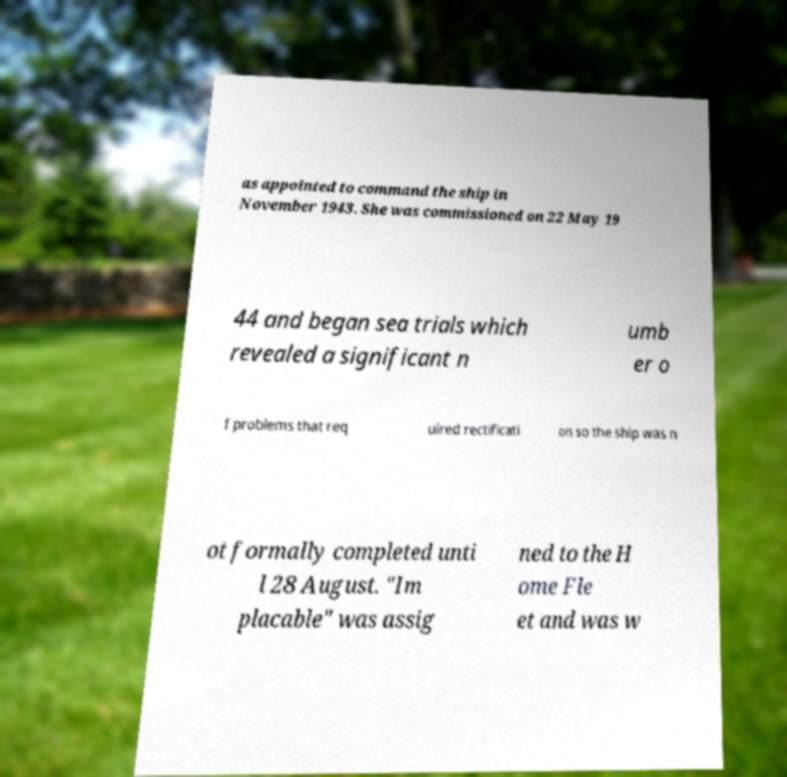Can you accurately transcribe the text from the provided image for me? as appointed to command the ship in November 1943. She was commissioned on 22 May 19 44 and began sea trials which revealed a significant n umb er o f problems that req uired rectificati on so the ship was n ot formally completed unti l 28 August. "Im placable" was assig ned to the H ome Fle et and was w 